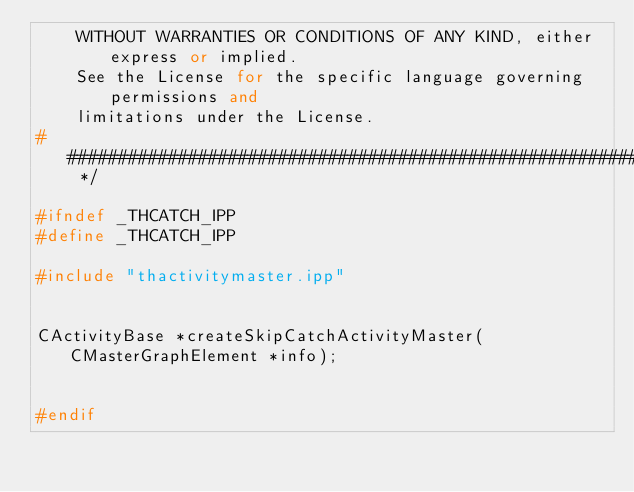Convert code to text. <code><loc_0><loc_0><loc_500><loc_500><_C++_>    WITHOUT WARRANTIES OR CONDITIONS OF ANY KIND, either express or implied.
    See the License for the specific language governing permissions and
    limitations under the License.
############################################################################## */

#ifndef _THCATCH_IPP
#define _THCATCH_IPP

#include "thactivitymaster.ipp"


CActivityBase *createSkipCatchActivityMaster(CMasterGraphElement *info);


#endif
</code> 